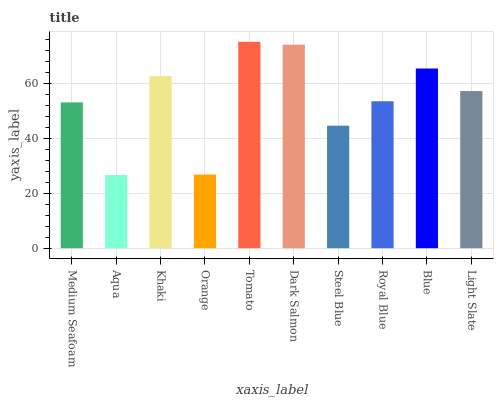Is Aqua the minimum?
Answer yes or no. Yes. Is Tomato the maximum?
Answer yes or no. Yes. Is Khaki the minimum?
Answer yes or no. No. Is Khaki the maximum?
Answer yes or no. No. Is Khaki greater than Aqua?
Answer yes or no. Yes. Is Aqua less than Khaki?
Answer yes or no. Yes. Is Aqua greater than Khaki?
Answer yes or no. No. Is Khaki less than Aqua?
Answer yes or no. No. Is Light Slate the high median?
Answer yes or no. Yes. Is Royal Blue the low median?
Answer yes or no. Yes. Is Orange the high median?
Answer yes or no. No. Is Tomato the low median?
Answer yes or no. No. 